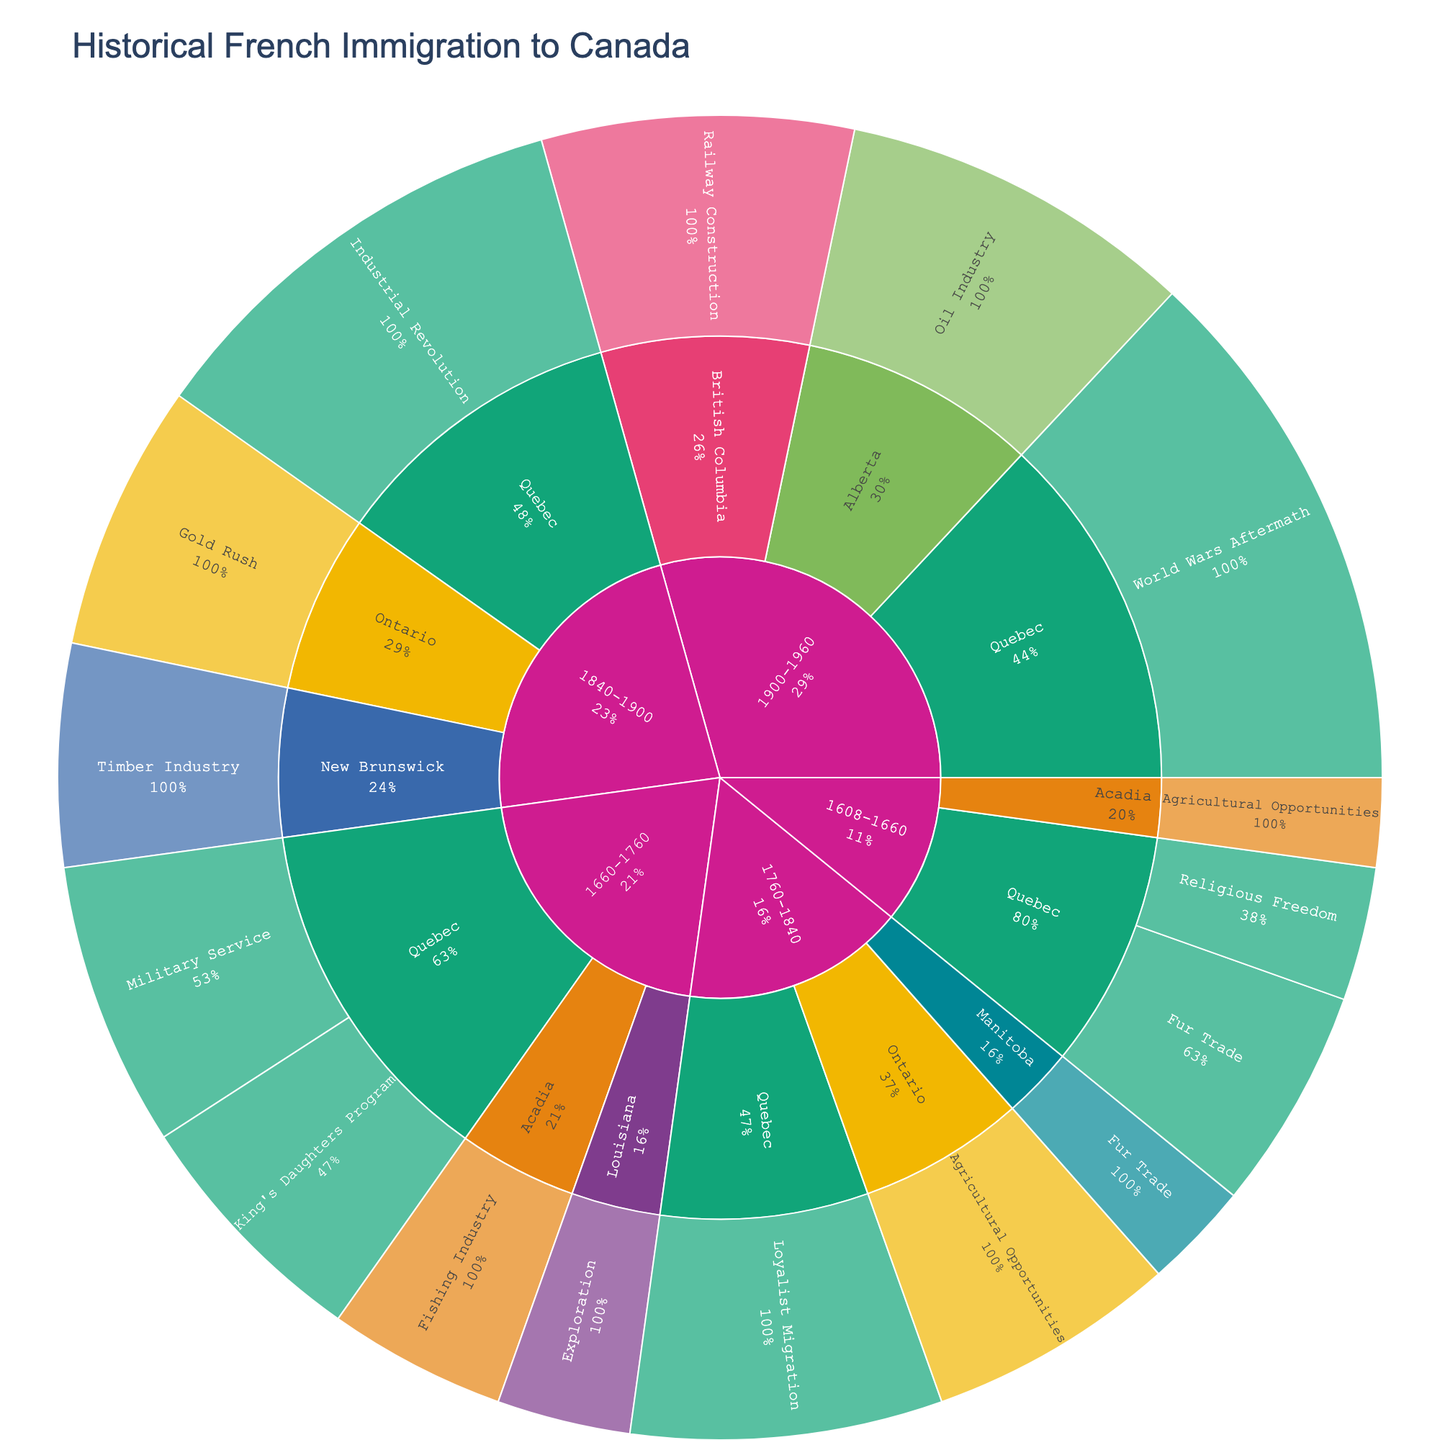Which time period had the highest population of French settlers migrating to Quebec for economic reasons? Look for the slice representing "Quebec" and identify periods labeled with economic reasons like "Fur Trade," "Industrial Revolution." Compare their population sums: 2500 (1608-1660) + 3200 (1660-1760) + 5000 (1840-1900). The highest is 5000.
Answer: 1840-1900 What was the primary reason for migration to British Columbia during 1900-1960? Search for the "1900-1960" period, then "British Columbia," noting the associated reason for migration. The label states "Railway Construction".
Answer: Railway Construction How does the population migrating to Alberta for the oil industry compare to the population migrating to New Brunswick for the timber industry? Identify "1900-1960" -> "Alberta" -> "Oil Industry" (4000) and "1840-1900" -> "New Brunswick" -> "Timber Industry" (2500). Compare: 4000 is greater than 2500.
Answer: Alberta has a higher population Which settlement region attracted French settlers due to religious freedom and in which time period? Look under "Religious Freedom" in the hierarchy and trace upwards. The settlement region is "Quebec" in "1608-1660".
Answer: Quebec, 1608-1660 What is the total population of French settlers in Acadia during 1608-1660? Find "1608-1660," sum populations under "Acadia": 1000 (Agricultural Opportunities) + 0 (no other values listed).
Answer: 1000 Compare the populations of settlers going to Quebec and Louisiana during 1660-1760. Which is higher and by how much? Locate "1660-1760," then sum populations for "Quebec" (2800 + 3200) and "Louisiana" (1500). Compare totals: Quebec (6000), Louisiana (1500). Difference: 6000 - 1500.
Answer: Quebec, by 4500 Which reason for migration had the largest population in Ontario during 1840-1900? Find "1840-1900," then "Ontario," and compare "Gold Rush" (3000). Gold Rush is the only reason, thus largest.
Answer: Gold Rush During 1760-1840, which region received the least French settlers and what was their reason for migration? Find "1760-1840" period, compare populations of regions: "Ontario" (2800), "Manitoba" (1200). Manitoba has the least settlers, reason is "Fur Trade".
Answer: Manitoba, Fur Trade 